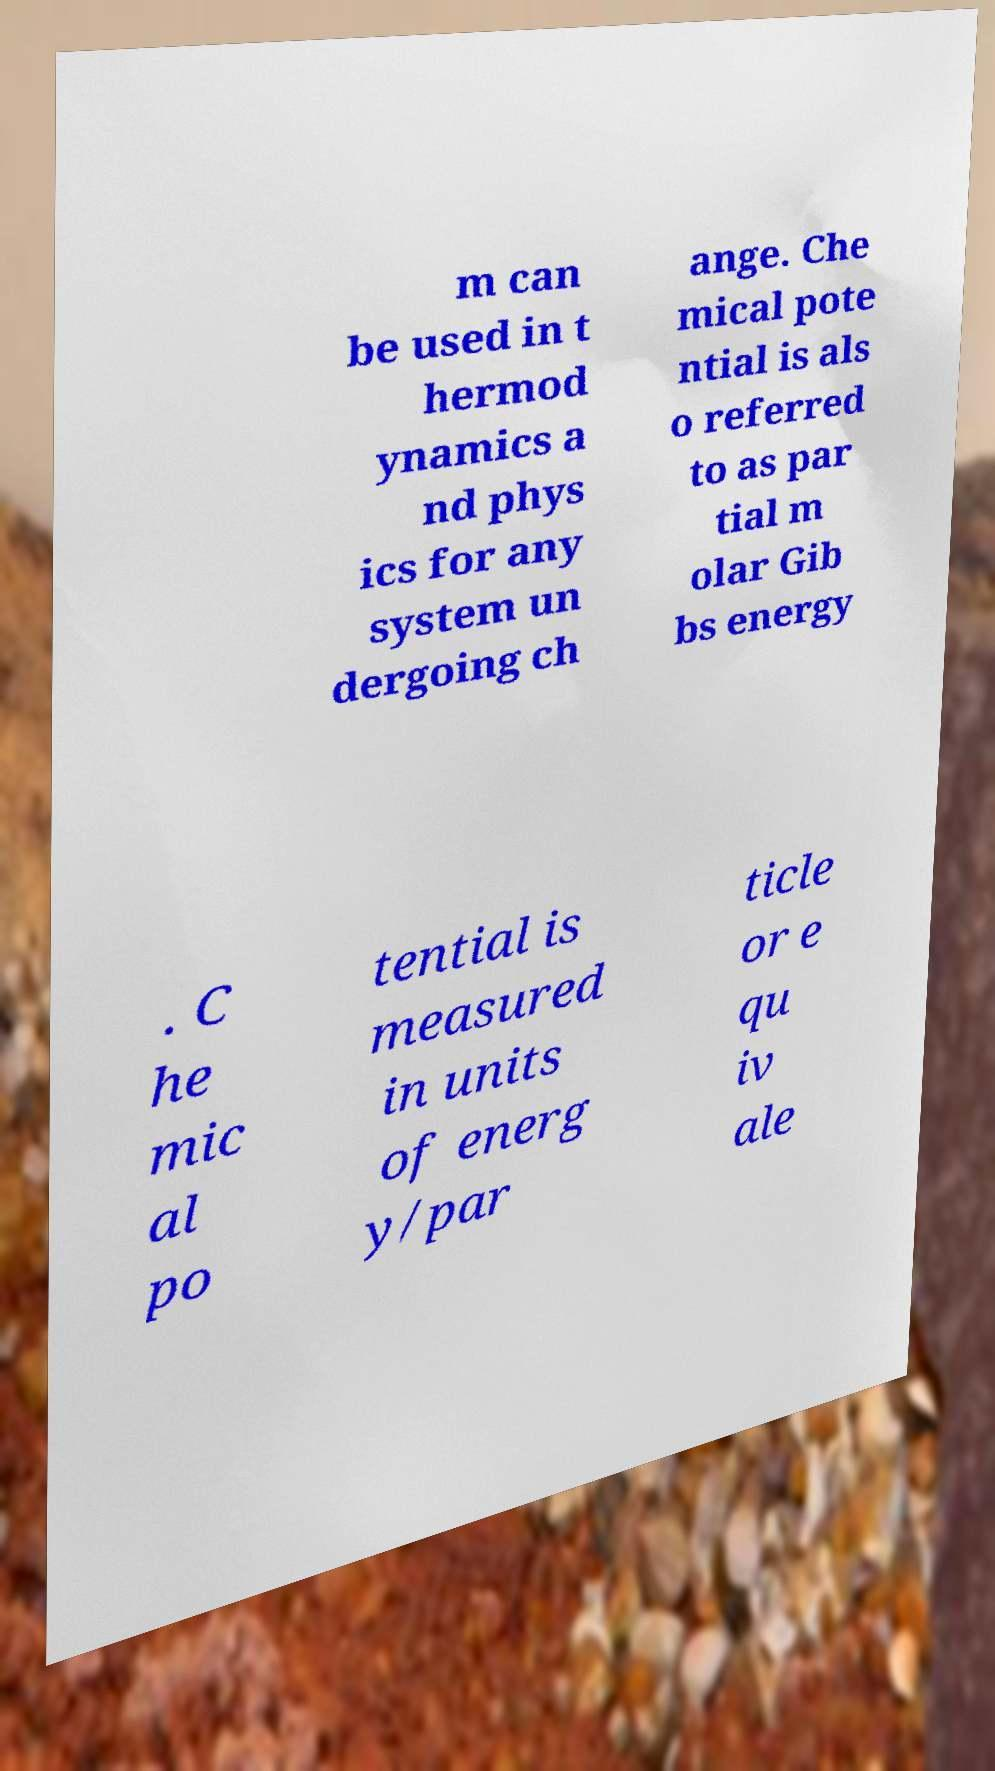Could you extract and type out the text from this image? m can be used in t hermod ynamics a nd phys ics for any system un dergoing ch ange. Che mical pote ntial is als o referred to as par tial m olar Gib bs energy . C he mic al po tential is measured in units of energ y/par ticle or e qu iv ale 